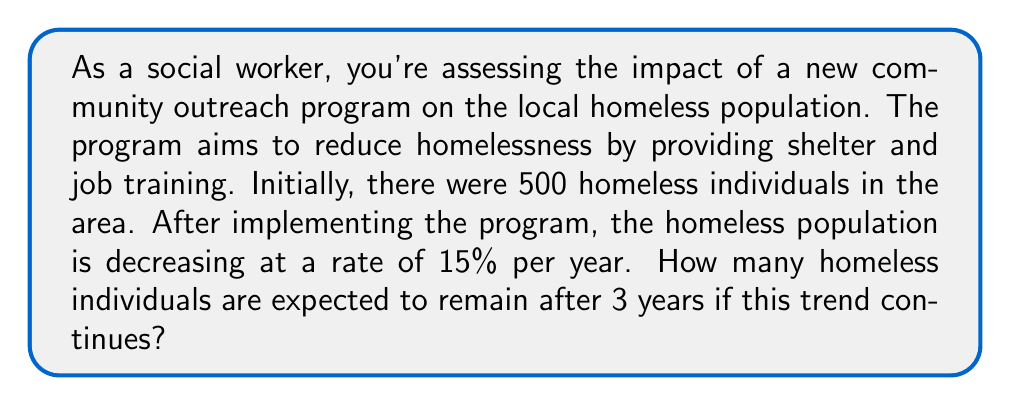Teach me how to tackle this problem. To solve this problem, we'll use an exponential decay function, which is a form of exponential growth with a negative rate.

1. Let's define our variables:
   $P_0 = 500$ (initial population)
   $r = -0.15$ (rate of decrease, expressed as a decimal)
   $t = 3$ (time in years)

2. The exponential function for population decay is:
   $P(t) = P_0 \cdot (1 + r)^t$

3. Substituting our values:
   $P(3) = 500 \cdot (1 - 0.15)^3$

4. Simplify inside the parentheses:
   $P(3) = 500 \cdot (0.85)^3$

5. Calculate the power:
   $P(3) = 500 \cdot 0.614125$

6. Multiply:
   $P(3) = 307.0625$

7. Round to the nearest whole number (as we're dealing with people):
   $P(3) \approx 307$

Therefore, after 3 years, approximately 307 homeless individuals are expected to remain.
Answer: 307 homeless individuals 